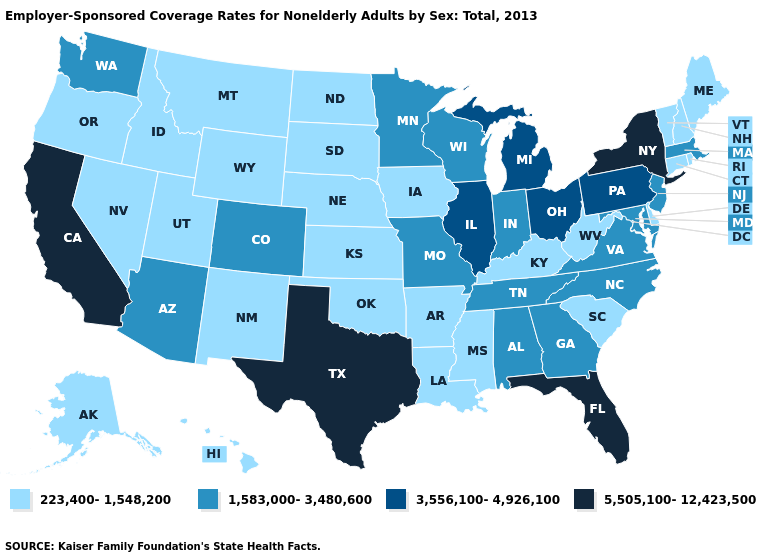Name the states that have a value in the range 3,556,100-4,926,100?
Quick response, please. Illinois, Michigan, Ohio, Pennsylvania. What is the value of New Jersey?
Keep it brief. 1,583,000-3,480,600. What is the highest value in the South ?
Keep it brief. 5,505,100-12,423,500. Name the states that have a value in the range 5,505,100-12,423,500?
Answer briefly. California, Florida, New York, Texas. Name the states that have a value in the range 223,400-1,548,200?
Be succinct. Alaska, Arkansas, Connecticut, Delaware, Hawaii, Idaho, Iowa, Kansas, Kentucky, Louisiana, Maine, Mississippi, Montana, Nebraska, Nevada, New Hampshire, New Mexico, North Dakota, Oklahoma, Oregon, Rhode Island, South Carolina, South Dakota, Utah, Vermont, West Virginia, Wyoming. Which states have the highest value in the USA?
Answer briefly. California, Florida, New York, Texas. What is the value of Alabama?
Keep it brief. 1,583,000-3,480,600. What is the highest value in the MidWest ?
Give a very brief answer. 3,556,100-4,926,100. What is the highest value in the South ?
Short answer required. 5,505,100-12,423,500. Which states have the lowest value in the South?
Concise answer only. Arkansas, Delaware, Kentucky, Louisiana, Mississippi, Oklahoma, South Carolina, West Virginia. What is the value of Colorado?
Concise answer only. 1,583,000-3,480,600. What is the highest value in the USA?
Keep it brief. 5,505,100-12,423,500. Does the first symbol in the legend represent the smallest category?
Quick response, please. Yes. Name the states that have a value in the range 1,583,000-3,480,600?
Concise answer only. Alabama, Arizona, Colorado, Georgia, Indiana, Maryland, Massachusetts, Minnesota, Missouri, New Jersey, North Carolina, Tennessee, Virginia, Washington, Wisconsin. What is the lowest value in the USA?
Be succinct. 223,400-1,548,200. 